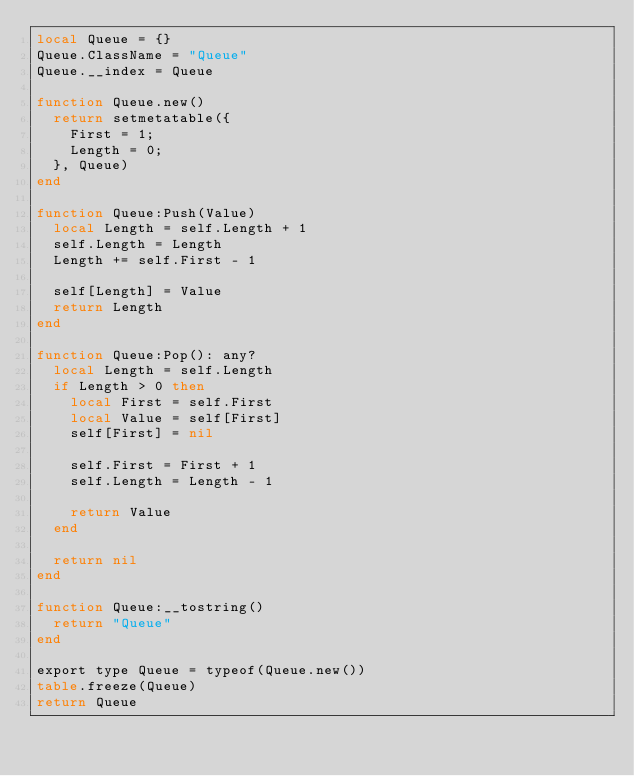<code> <loc_0><loc_0><loc_500><loc_500><_Lua_>local Queue = {}
Queue.ClassName = "Queue"
Queue.__index = Queue

function Queue.new()
	return setmetatable({
		First = 1;
		Length = 0;
	}, Queue)
end

function Queue:Push(Value)
	local Length = self.Length + 1
	self.Length = Length
	Length += self.First - 1

	self[Length] = Value
	return Length
end

function Queue:Pop(): any?
	local Length = self.Length
	if Length > 0 then
		local First = self.First
		local Value = self[First]
		self[First] = nil

		self.First = First + 1
		self.Length = Length - 1

		return Value
	end

	return nil
end

function Queue:__tostring()
	return "Queue"
end

export type Queue = typeof(Queue.new())
table.freeze(Queue)
return Queue
</code> 